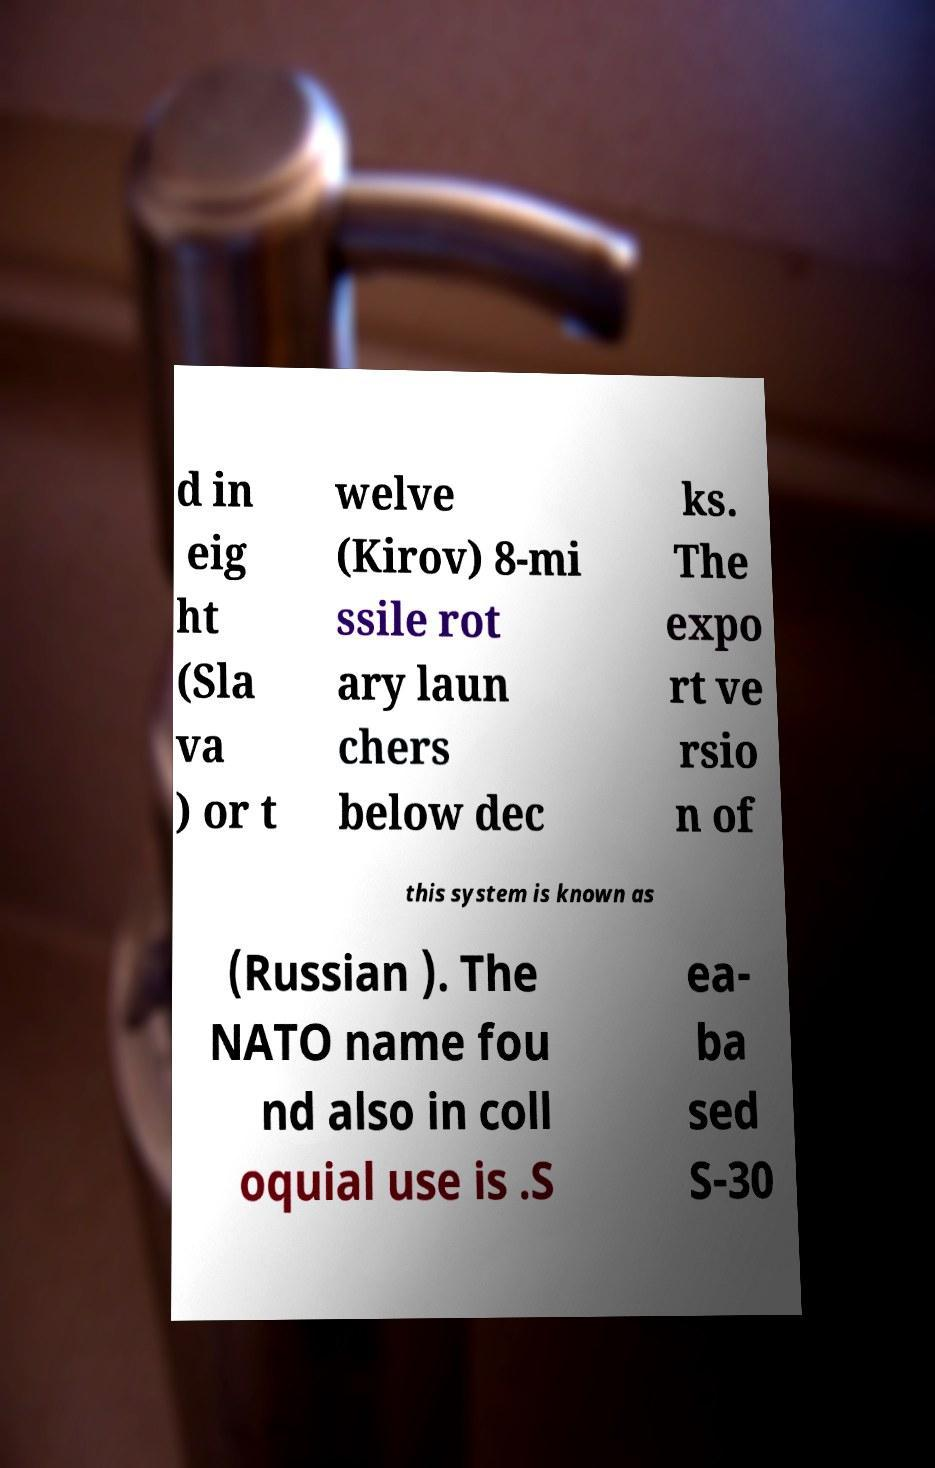Could you extract and type out the text from this image? d in eig ht (Sla va ) or t welve (Kirov) 8-mi ssile rot ary laun chers below dec ks. The expo rt ve rsio n of this system is known as (Russian ). The NATO name fou nd also in coll oquial use is .S ea- ba sed S-30 